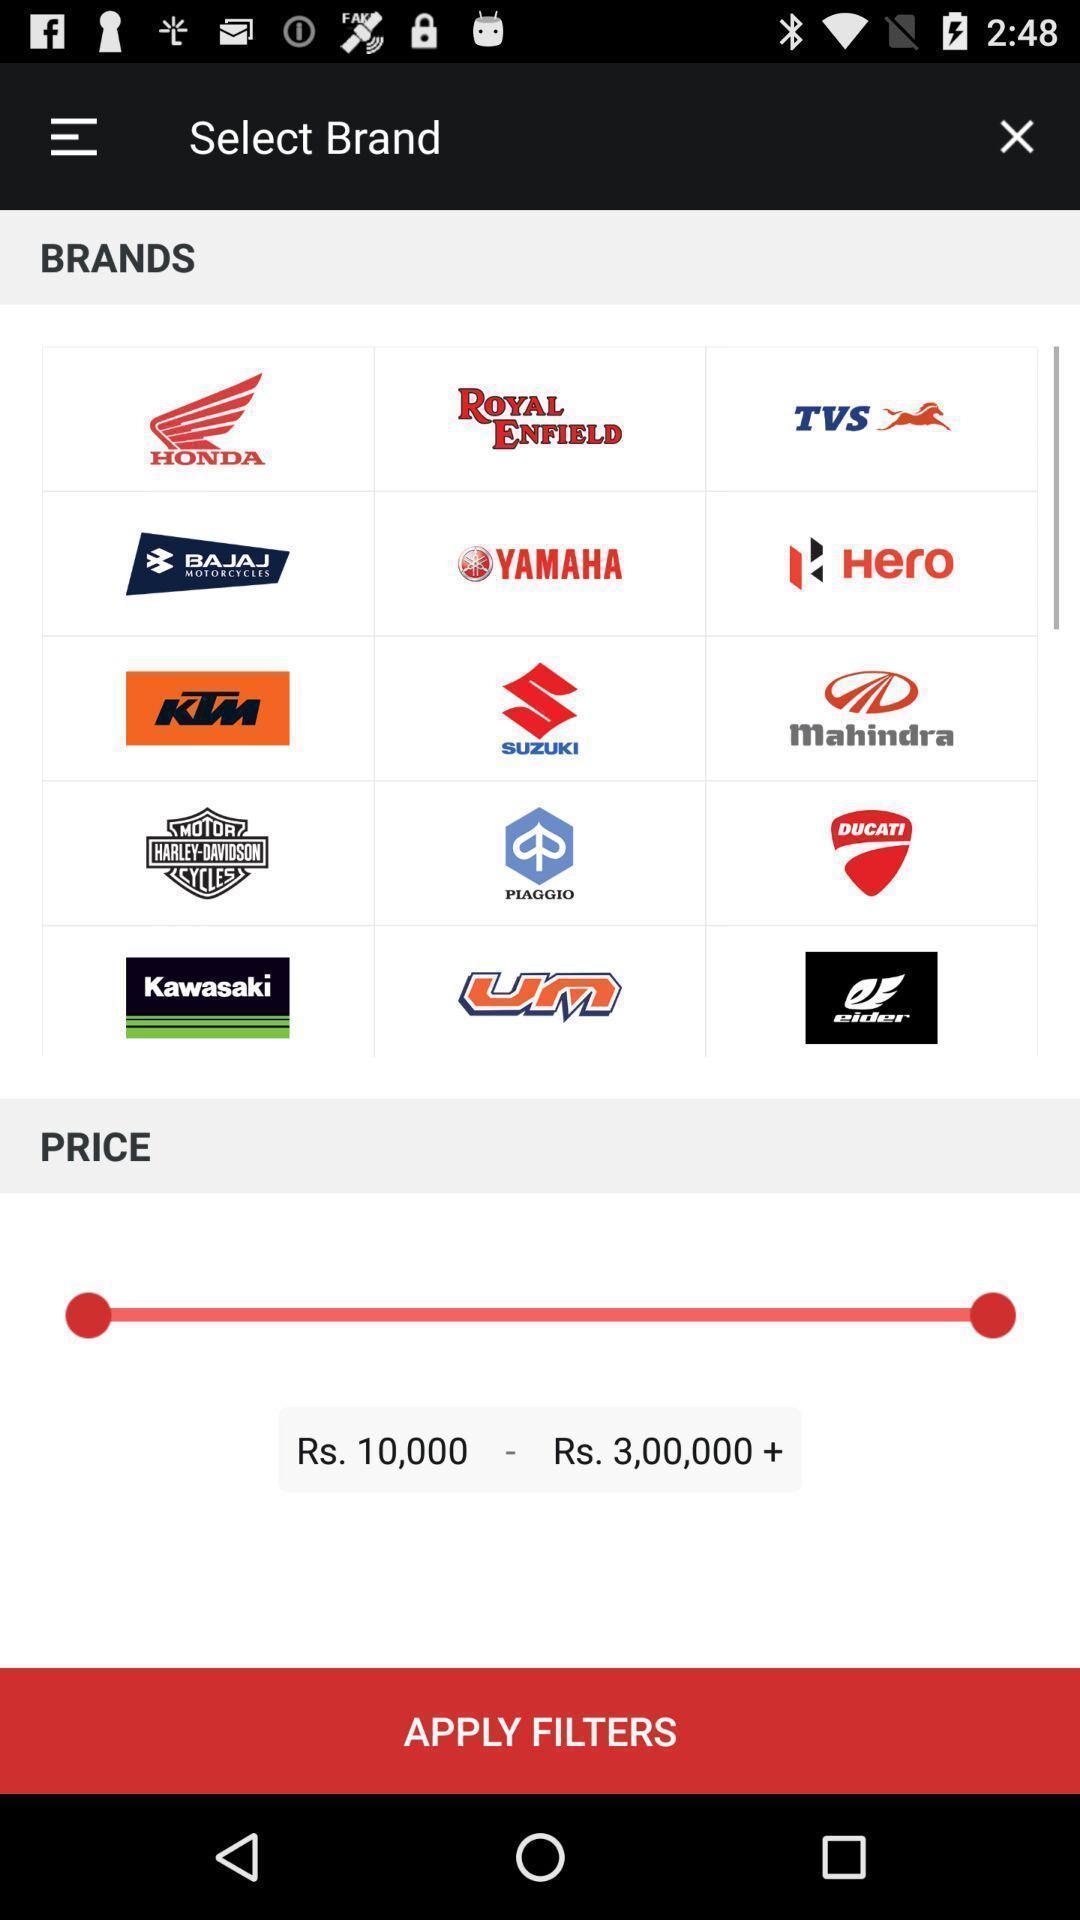Tell me about the visual elements in this screen capture. Screen displaying list of brands on a shopping app. 